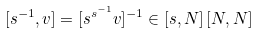<formula> <loc_0><loc_0><loc_500><loc_500>[ s ^ { - 1 } , v ] = [ s ^ { s ^ { - 1 } } v ] ^ { - 1 } \in [ s , N ] \, [ N , N ]</formula> 